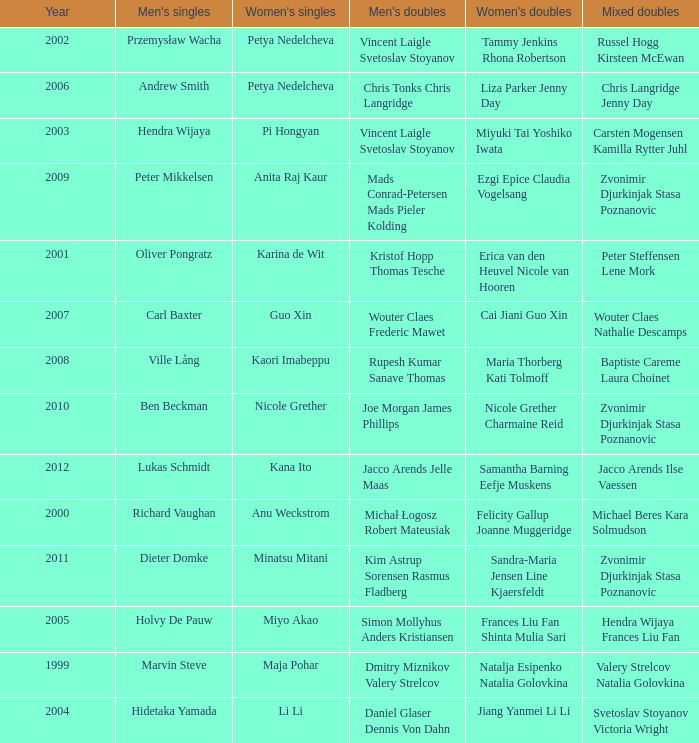Give the earliest year that featured Pi Hongyan on women's singles. 2003.0. 